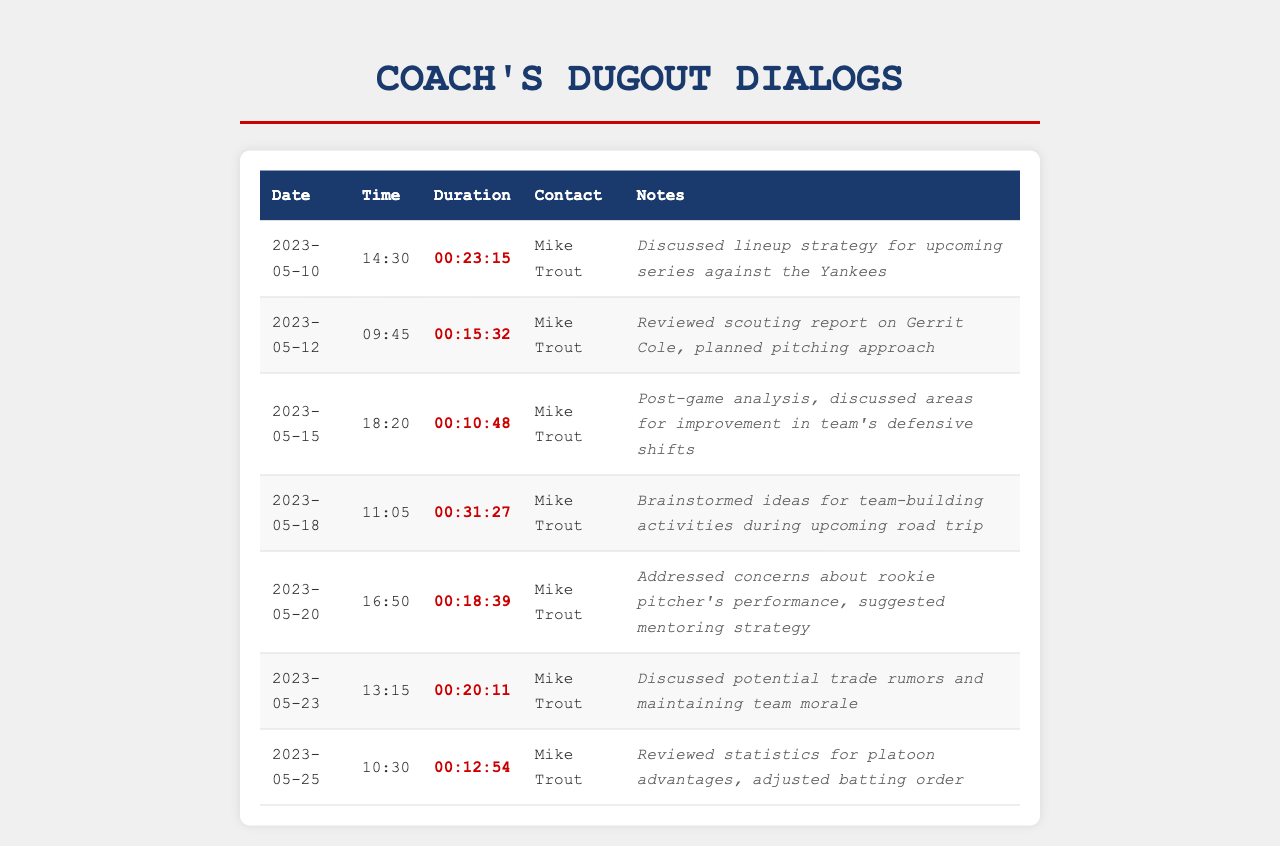What is the date of the call with the longest duration? The longest duration is 00:31:27, which occurred on May 18, 2023.
Answer: 2023-05-18 Who is the contact for all the calls in this log? Each call in the log is with the same contact, Mike Trout.
Answer: Mike Trout How long was the call on May 12, 2023? The duration of the call on this date is 00:15:32.
Answer: 00:15:32 What was discussed during the call on May 20, 2023? The notes indicate a concern about a rookie pitcher's performance and a mentoring strategy was suggested.
Answer: Rookie pitcher's performance Which date had the shortest call duration? The shortest call duration is 00:10:48 on May 15, 2023.
Answer: 00:10:48 How many calls were made to Mike Trout in May 2023? There are a total of seven calls recorded in May 2023.
Answer: 7 What was the main topic of discussion in the call on May 23, 2023? The primary focus was on potential trade rumors and maintaining team morale.
Answer: Trade rumors What time was the call on May 18, 2023? The time of the call on this date was 11:05 AM.
Answer: 11:05 What type of activities were brainstormed during the call on May 18, 2023? Ideas for team-building activities were brainstormed during this call.
Answer: Team-building activities 